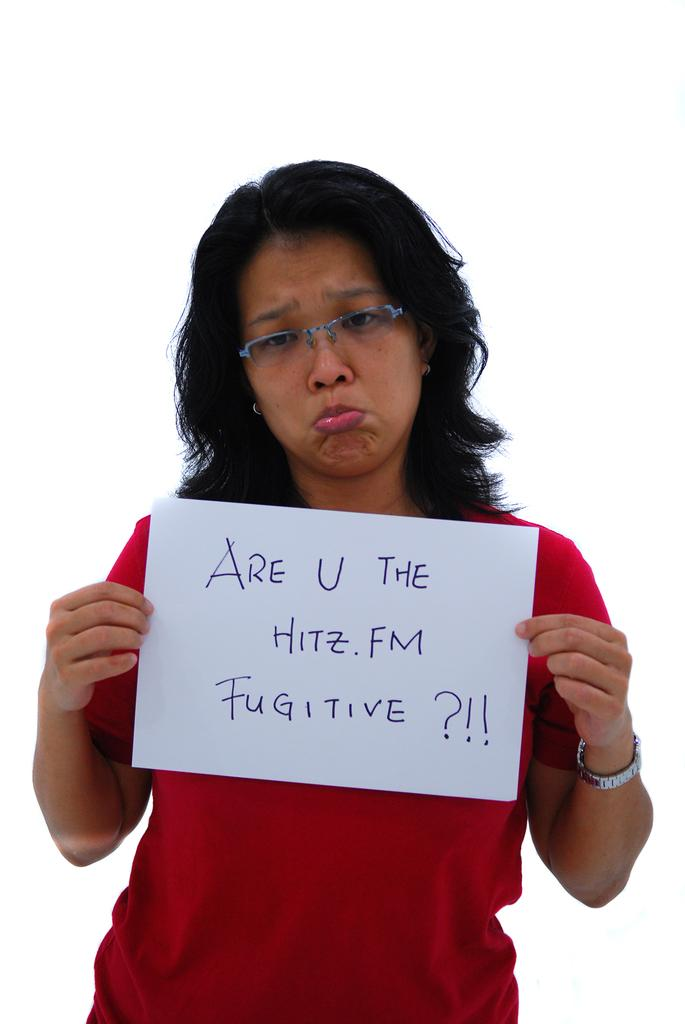Provide a one-sentence caption for the provided image. A woman frowning and holding a sign asking about 'HITZ.FM FUGITIVES.'. 